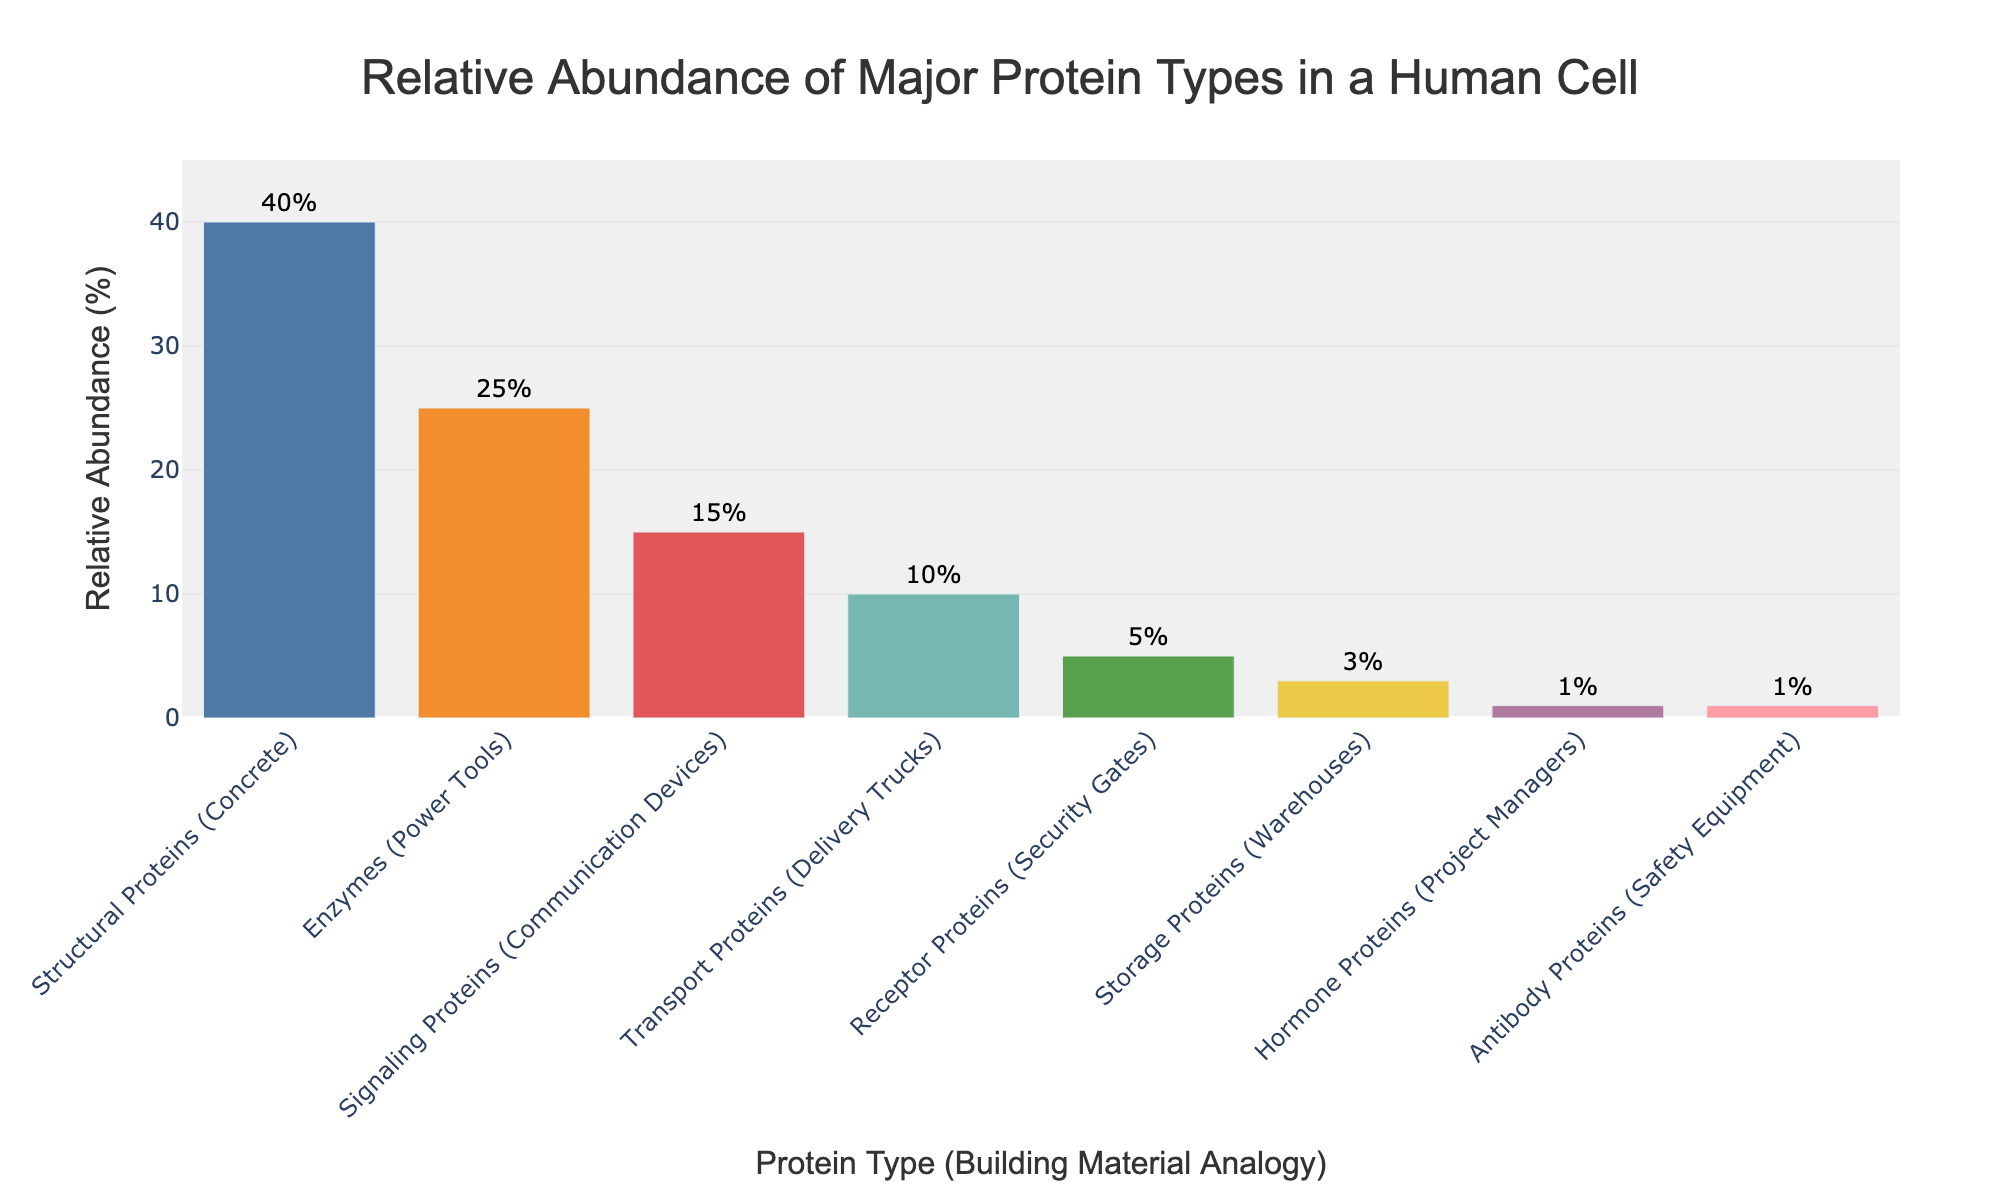What's the relative abundance of Enzymes (Power Tools) in a human cell? Locate the bar labeled "Enzymes (Power Tools)" on the x-axis and check the corresponding value on the y-axis, which reveals the percentage.
Answer: 25% What is the combined relative abundance of Structural Proteins (Concrete) and Transport Proteins (Delivery Trucks)? Sum up the values corresponding to "Structural Proteins (Concrete)" (40%) and "Transport Proteins (Delivery Trucks)" (10%) from the y-axis.
Answer: 50% Which protein type has the lowest relative abundance? Identify the bar with the shortest height on the plot. The label "Hormone Proteins (Project Managers)" and "Antibody Proteins (Safety Equipment)" both indicate 1%, the lowest percentage.
Answer: Hormone Proteins and Antibody Proteins Are there more Structural Proteins (Concrete) or Signaling Proteins (Communication Devices)? Compare the heights of the bars labeled "Structural Proteins (Concrete)" and "Signaling Proteins (Communication Devices)". Structural Proteins (Concrete) at 40% is higher than Signaling Proteins (Communication Devices) at 15%.
Answer: Structural Proteins What's the difference in percentage between Receptor Proteins (Security Gates) and Storage Proteins (Warehouses)? Find the difference between the bars for "Receptor Proteins (Security Gates)" (5%) and "Storage Proteins (Warehouses)" (3%) by subtracting the values.
Answer: 2% Which protein types represent communication tools in our analogy, and what is their total percentage? Identify labels with "communication" analogies: "Signaling Proteins (Communication Devices)". The total percentage is simply that of Signaling Proteins (Communication Devices), 15%.
Answer: Signaling Proteins, 15% What percentage of proteins are either Enzymes (Power Tools) or Storage Proteins (Warehouses)? Sum the values for "Enzymes (Power Tools)" (25%) and "Storage Proteins (Warehouses)" (3%).
Answer: 28% Among the depicted protein types, which has the closest abundance percentage to 10%? Locate the bar values close to 10%; "Transport Proteins (Delivery Trucks)" is exactly at 10%.
Answer: Transport Proteins How much more abundant are Structural Proteins (Concrete) compared to Enzymes (Power Tools)? Subtract the percentage of Enzymes (Power Tools) (25%) from that of Structural Proteins (Concrete) (40%).
Answer: 15% 